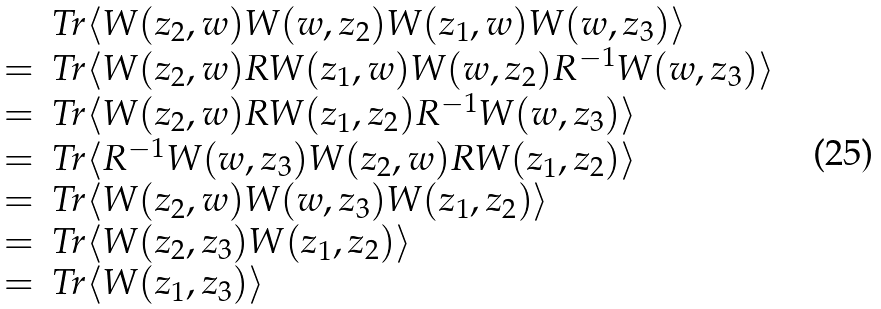<formula> <loc_0><loc_0><loc_500><loc_500>\begin{array} { r l } & T r \langle W ( z _ { 2 } , w ) W ( w , z _ { 2 } ) W ( z _ { 1 } , w ) W ( w , z _ { 3 } ) \rangle \\ = & T r \langle W ( z _ { 2 } , w ) R W ( z _ { 1 } , w ) W ( w , z _ { 2 } ) R ^ { - 1 } W ( w , z _ { 3 } ) \rangle \\ = & T r \langle W ( z _ { 2 } , w ) R W ( z _ { 1 } , z _ { 2 } ) R ^ { - 1 } W ( w , z _ { 3 } ) \rangle \\ = & T r \langle R ^ { - 1 } W ( w , z _ { 3 } ) W ( z _ { 2 } , w ) R W ( z _ { 1 } , z _ { 2 } ) \rangle \\ = & T r \langle W ( z _ { 2 } , w ) W ( w , z _ { 3 } ) W ( z _ { 1 } , z _ { 2 } ) \rangle \\ = & T r \langle W ( z _ { 2 } , z _ { 3 } ) W ( z _ { 1 } , z _ { 2 } ) \rangle \\ = & T r \langle W ( z _ { 1 } , z _ { 3 } ) \rangle \\ \end{array}</formula> 